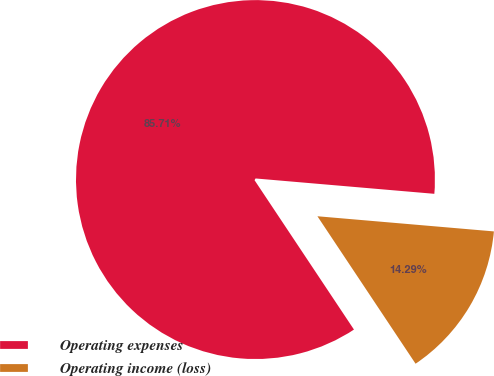<chart> <loc_0><loc_0><loc_500><loc_500><pie_chart><fcel>Operating expenses<fcel>Operating income (loss)<nl><fcel>85.71%<fcel>14.29%<nl></chart> 